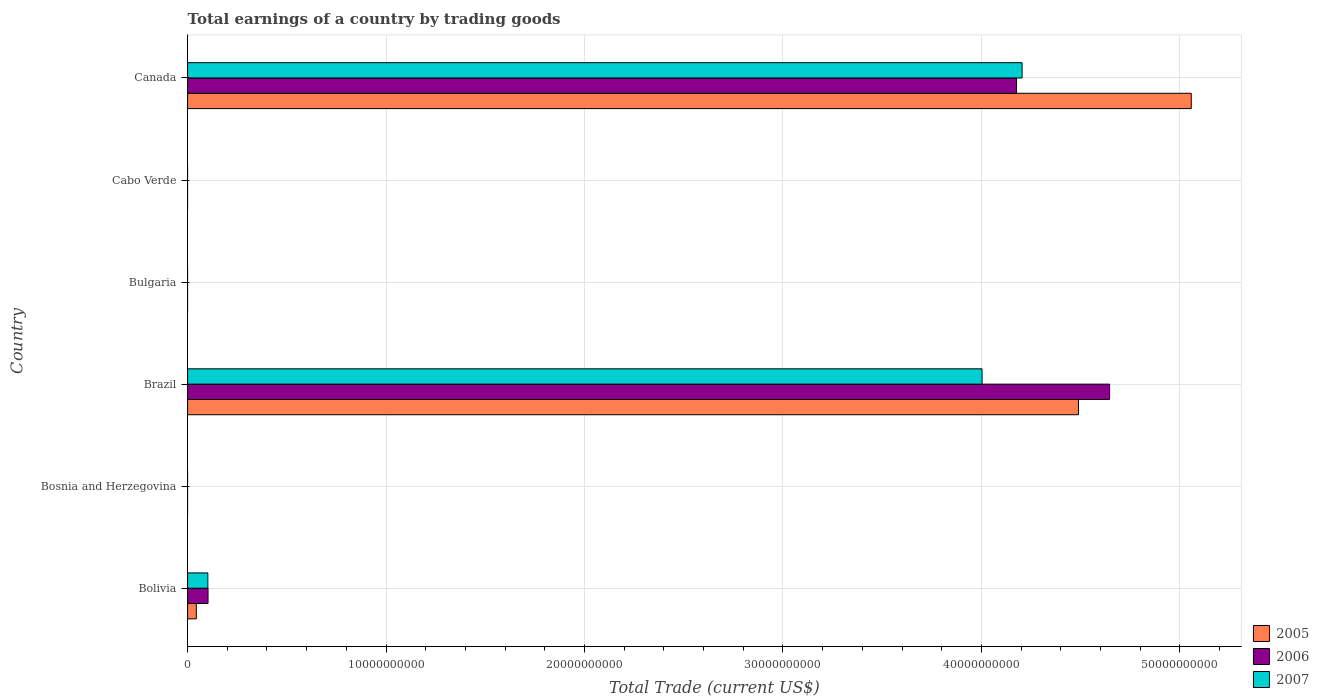How many different coloured bars are there?
Provide a short and direct response. 3. Are the number of bars per tick equal to the number of legend labels?
Your answer should be very brief. No. Are the number of bars on each tick of the Y-axis equal?
Offer a terse response. No. In how many cases, is the number of bars for a given country not equal to the number of legend labels?
Offer a terse response. 3. Across all countries, what is the maximum total earnings in 2007?
Make the answer very short. 4.20e+1. What is the total total earnings in 2005 in the graph?
Offer a very short reply. 9.59e+1. What is the difference between the total earnings in 2005 in Bolivia and that in Brazil?
Your response must be concise. -4.44e+1. What is the difference between the total earnings in 2006 in Canada and the total earnings in 2005 in Brazil?
Your answer should be very brief. -3.12e+09. What is the average total earnings in 2006 per country?
Provide a succinct answer. 1.49e+1. What is the difference between the total earnings in 2005 and total earnings in 2006 in Bolivia?
Make the answer very short. -5.90e+08. What is the ratio of the total earnings in 2005 in Bolivia to that in Brazil?
Provide a short and direct response. 0.01. Is the total earnings in 2007 in Brazil less than that in Canada?
Your response must be concise. Yes. What is the difference between the highest and the second highest total earnings in 2005?
Keep it short and to the point. 5.68e+09. What is the difference between the highest and the lowest total earnings in 2007?
Offer a terse response. 4.20e+1. Is the sum of the total earnings in 2007 in Bolivia and Brazil greater than the maximum total earnings in 2006 across all countries?
Make the answer very short. No. How many countries are there in the graph?
Offer a very short reply. 6. What is the difference between two consecutive major ticks on the X-axis?
Ensure brevity in your answer.  1.00e+1. Are the values on the major ticks of X-axis written in scientific E-notation?
Provide a succinct answer. No. Does the graph contain any zero values?
Provide a short and direct response. Yes. Does the graph contain grids?
Keep it short and to the point. Yes. How are the legend labels stacked?
Your answer should be compact. Vertical. What is the title of the graph?
Keep it short and to the point. Total earnings of a country by trading goods. What is the label or title of the X-axis?
Ensure brevity in your answer.  Total Trade (current US$). What is the Total Trade (current US$) in 2005 in Bolivia?
Ensure brevity in your answer.  4.40e+08. What is the Total Trade (current US$) of 2006 in Bolivia?
Make the answer very short. 1.03e+09. What is the Total Trade (current US$) in 2007 in Bolivia?
Offer a very short reply. 1.02e+09. What is the Total Trade (current US$) of 2005 in Bosnia and Herzegovina?
Provide a succinct answer. 0. What is the Total Trade (current US$) of 2006 in Bosnia and Herzegovina?
Give a very brief answer. 0. What is the Total Trade (current US$) of 2005 in Brazil?
Ensure brevity in your answer.  4.49e+1. What is the Total Trade (current US$) in 2006 in Brazil?
Give a very brief answer. 4.65e+1. What is the Total Trade (current US$) in 2007 in Brazil?
Provide a short and direct response. 4.00e+1. What is the Total Trade (current US$) in 2005 in Bulgaria?
Provide a succinct answer. 0. What is the Total Trade (current US$) in 2006 in Bulgaria?
Keep it short and to the point. 0. What is the Total Trade (current US$) in 2005 in Cabo Verde?
Give a very brief answer. 0. What is the Total Trade (current US$) of 2007 in Cabo Verde?
Offer a terse response. 0. What is the Total Trade (current US$) of 2005 in Canada?
Offer a terse response. 5.06e+1. What is the Total Trade (current US$) in 2006 in Canada?
Give a very brief answer. 4.18e+1. What is the Total Trade (current US$) of 2007 in Canada?
Your response must be concise. 4.20e+1. Across all countries, what is the maximum Total Trade (current US$) of 2005?
Make the answer very short. 5.06e+1. Across all countries, what is the maximum Total Trade (current US$) of 2006?
Keep it short and to the point. 4.65e+1. Across all countries, what is the maximum Total Trade (current US$) of 2007?
Keep it short and to the point. 4.20e+1. Across all countries, what is the minimum Total Trade (current US$) of 2005?
Your answer should be compact. 0. Across all countries, what is the minimum Total Trade (current US$) in 2007?
Your answer should be very brief. 0. What is the total Total Trade (current US$) of 2005 in the graph?
Provide a short and direct response. 9.59e+1. What is the total Total Trade (current US$) in 2006 in the graph?
Offer a very short reply. 8.93e+1. What is the total Total Trade (current US$) of 2007 in the graph?
Give a very brief answer. 8.31e+1. What is the difference between the Total Trade (current US$) of 2005 in Bolivia and that in Brazil?
Make the answer very short. -4.44e+1. What is the difference between the Total Trade (current US$) in 2006 in Bolivia and that in Brazil?
Give a very brief answer. -4.54e+1. What is the difference between the Total Trade (current US$) of 2007 in Bolivia and that in Brazil?
Offer a terse response. -3.90e+1. What is the difference between the Total Trade (current US$) in 2005 in Bolivia and that in Canada?
Your answer should be compact. -5.01e+1. What is the difference between the Total Trade (current US$) in 2006 in Bolivia and that in Canada?
Provide a short and direct response. -4.07e+1. What is the difference between the Total Trade (current US$) of 2007 in Bolivia and that in Canada?
Keep it short and to the point. -4.10e+1. What is the difference between the Total Trade (current US$) in 2005 in Brazil and that in Canada?
Offer a very short reply. -5.68e+09. What is the difference between the Total Trade (current US$) of 2006 in Brazil and that in Canada?
Give a very brief answer. 4.69e+09. What is the difference between the Total Trade (current US$) of 2007 in Brazil and that in Canada?
Provide a succinct answer. -2.02e+09. What is the difference between the Total Trade (current US$) of 2005 in Bolivia and the Total Trade (current US$) of 2006 in Brazil?
Offer a very short reply. -4.60e+1. What is the difference between the Total Trade (current US$) of 2005 in Bolivia and the Total Trade (current US$) of 2007 in Brazil?
Offer a very short reply. -3.96e+1. What is the difference between the Total Trade (current US$) of 2006 in Bolivia and the Total Trade (current US$) of 2007 in Brazil?
Ensure brevity in your answer.  -3.90e+1. What is the difference between the Total Trade (current US$) of 2005 in Bolivia and the Total Trade (current US$) of 2006 in Canada?
Make the answer very short. -4.13e+1. What is the difference between the Total Trade (current US$) in 2005 in Bolivia and the Total Trade (current US$) in 2007 in Canada?
Make the answer very short. -4.16e+1. What is the difference between the Total Trade (current US$) in 2006 in Bolivia and the Total Trade (current US$) in 2007 in Canada?
Make the answer very short. -4.10e+1. What is the difference between the Total Trade (current US$) in 2005 in Brazil and the Total Trade (current US$) in 2006 in Canada?
Your response must be concise. 3.12e+09. What is the difference between the Total Trade (current US$) in 2005 in Brazil and the Total Trade (current US$) in 2007 in Canada?
Ensure brevity in your answer.  2.84e+09. What is the difference between the Total Trade (current US$) of 2006 in Brazil and the Total Trade (current US$) of 2007 in Canada?
Your answer should be compact. 4.41e+09. What is the average Total Trade (current US$) of 2005 per country?
Provide a short and direct response. 1.60e+1. What is the average Total Trade (current US$) in 2006 per country?
Your response must be concise. 1.49e+1. What is the average Total Trade (current US$) in 2007 per country?
Your answer should be very brief. 1.38e+1. What is the difference between the Total Trade (current US$) in 2005 and Total Trade (current US$) in 2006 in Bolivia?
Provide a short and direct response. -5.90e+08. What is the difference between the Total Trade (current US$) in 2005 and Total Trade (current US$) in 2007 in Bolivia?
Your response must be concise. -5.80e+08. What is the difference between the Total Trade (current US$) in 2006 and Total Trade (current US$) in 2007 in Bolivia?
Your answer should be compact. 1.05e+07. What is the difference between the Total Trade (current US$) of 2005 and Total Trade (current US$) of 2006 in Brazil?
Provide a short and direct response. -1.57e+09. What is the difference between the Total Trade (current US$) in 2005 and Total Trade (current US$) in 2007 in Brazil?
Offer a very short reply. 4.86e+09. What is the difference between the Total Trade (current US$) in 2006 and Total Trade (current US$) in 2007 in Brazil?
Offer a terse response. 6.43e+09. What is the difference between the Total Trade (current US$) of 2005 and Total Trade (current US$) of 2006 in Canada?
Your answer should be very brief. 8.80e+09. What is the difference between the Total Trade (current US$) of 2005 and Total Trade (current US$) of 2007 in Canada?
Offer a very short reply. 8.52e+09. What is the difference between the Total Trade (current US$) in 2006 and Total Trade (current US$) in 2007 in Canada?
Your answer should be very brief. -2.80e+08. What is the ratio of the Total Trade (current US$) in 2005 in Bolivia to that in Brazil?
Make the answer very short. 0.01. What is the ratio of the Total Trade (current US$) of 2006 in Bolivia to that in Brazil?
Your response must be concise. 0.02. What is the ratio of the Total Trade (current US$) in 2007 in Bolivia to that in Brazil?
Provide a succinct answer. 0.03. What is the ratio of the Total Trade (current US$) in 2005 in Bolivia to that in Canada?
Your response must be concise. 0.01. What is the ratio of the Total Trade (current US$) in 2006 in Bolivia to that in Canada?
Ensure brevity in your answer.  0.02. What is the ratio of the Total Trade (current US$) in 2007 in Bolivia to that in Canada?
Your answer should be very brief. 0.02. What is the ratio of the Total Trade (current US$) of 2005 in Brazil to that in Canada?
Your answer should be compact. 0.89. What is the ratio of the Total Trade (current US$) in 2006 in Brazil to that in Canada?
Give a very brief answer. 1.11. What is the difference between the highest and the second highest Total Trade (current US$) in 2005?
Your answer should be very brief. 5.68e+09. What is the difference between the highest and the second highest Total Trade (current US$) in 2006?
Make the answer very short. 4.69e+09. What is the difference between the highest and the second highest Total Trade (current US$) in 2007?
Give a very brief answer. 2.02e+09. What is the difference between the highest and the lowest Total Trade (current US$) in 2005?
Your response must be concise. 5.06e+1. What is the difference between the highest and the lowest Total Trade (current US$) of 2006?
Your response must be concise. 4.65e+1. What is the difference between the highest and the lowest Total Trade (current US$) of 2007?
Your response must be concise. 4.20e+1. 